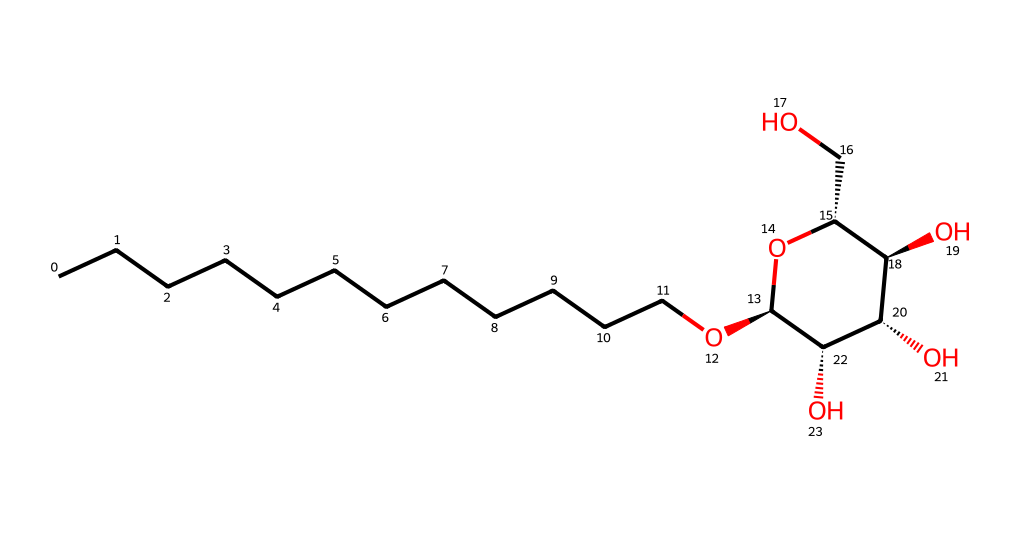What is the main functional group present in this chemical? The chemical structure features multiple -OH groups (hydroxyl groups), indicating that it's a polyol. These hydroxyl groups are characteristic of surfactants, which can help reduce surface tension.
Answer: hydroxyl How many carbon atoms are in the longest carbon chain? By examining the linear part of the structure, the longest continuous chain of carbon atoms is found to have 12 carbons, which corresponds to the dodecyl portion of the molecule.
Answer: 12 What type of surfactant is indicated by this chemical structure? This structure suggests it is a non-ionic surfactant because it contains no charged functional groups. Non-ionic surfactants are typically characterized by the presence of hydrophilic groups, such as polyglucosides, combined with hydrophobic alkyl chains.
Answer: non-ionic What is the total number of oxygen atoms in the molecule? Analyzing the structure, there are 4 oxygen atoms present: one in the alkyl chain and three in the glycosidic part of the molecule. This relates to the surfactant’s properties and its ability to interact with both water and oils.
Answer: 4 Does this molecule exhibit any branching in its carbon chain? Upon evaluation, the linear carbon chain is unbranched, consisting of consecutive carbon atoms. Unbranched structures generally help in consistent detergent action due to even distribution of molecules during usage.
Answer: no How does this structure promote eco-friendliness? The presence of natural raw material-derived groups such as glucose in its structure extends its biodegradability, making this surfactant more environmentally friendly compared to synthetic alternatives. This property is crucial for eco-friendly cleaning products.
Answer: biodegradability 